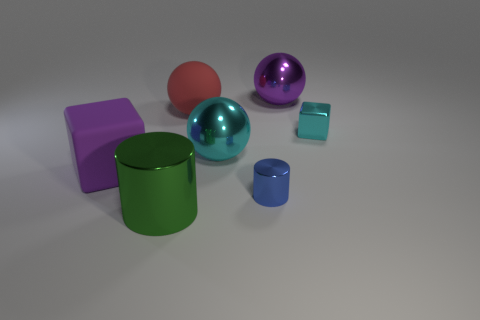What number of other objects are there of the same shape as the large green object?
Offer a terse response. 1. Does the red rubber thing have the same shape as the blue metal object that is in front of the cyan metal cube?
Your response must be concise. No. There is a tiny cyan object; how many large red balls are left of it?
Provide a short and direct response. 1. Does the small object that is in front of the large purple cube have the same shape as the large green shiny object?
Give a very brief answer. Yes. The block that is behind the purple matte thing is what color?
Keep it short and to the point. Cyan. There is a purple thing that is made of the same material as the tiny cyan block; what shape is it?
Offer a very short reply. Sphere. Is there anything else of the same color as the tiny metallic block?
Ensure brevity in your answer.  Yes. Is the number of cylinders that are to the right of the big rubber sphere greater than the number of cyan blocks on the left side of the large block?
Your response must be concise. Yes. What number of cyan things have the same size as the blue object?
Make the answer very short. 1. Is the number of big green metallic cylinders behind the large green thing less than the number of big metal balls behind the tiny cylinder?
Provide a succinct answer. Yes. 